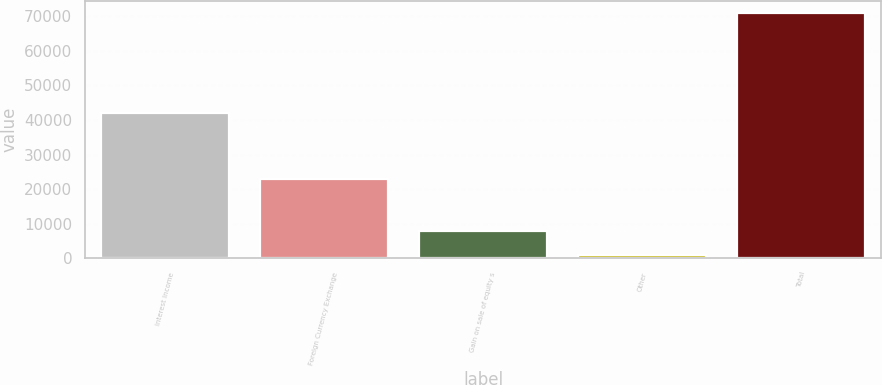Convert chart to OTSL. <chart><loc_0><loc_0><loc_500><loc_500><bar_chart><fcel>Interest Income<fcel>Foreign Currency Exchange<fcel>Gain on sale of equity s<fcel>Other<fcel>Total<nl><fcel>41995<fcel>22964<fcel>7868<fcel>862<fcel>70922<nl></chart> 